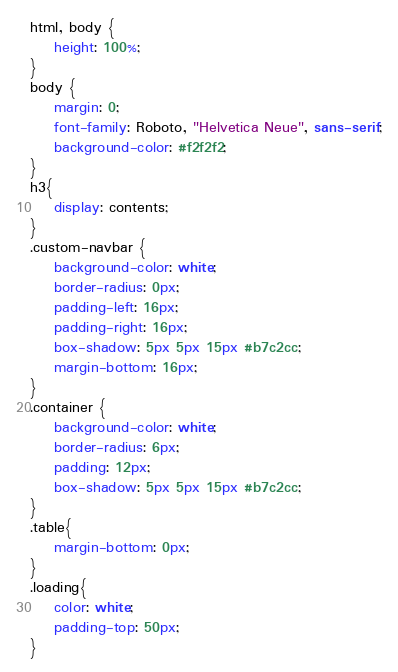Convert code to text. <code><loc_0><loc_0><loc_500><loc_500><_CSS_>html, body { 
    height: 100%; 
}
body { 
    margin: 0;
    font-family: Roboto, "Helvetica Neue", sans-serif;
    background-color: #f2f2f2;
}
h3{
    display: contents;
}
.custom-navbar {
    background-color: white;
    border-radius: 0px;
    padding-left: 16px;
    padding-right: 16px;
    box-shadow: 5px 5px 15px #b7c2cc;
    margin-bottom: 16px;
}
.container {
    background-color: white;
    border-radius: 6px;
    padding: 12px;
    box-shadow: 5px 5px 15px #b7c2cc;    
}
.table{
    margin-bottom: 0px;
}
.loading{
    color: white;
    padding-top: 50px;
}
</code> 